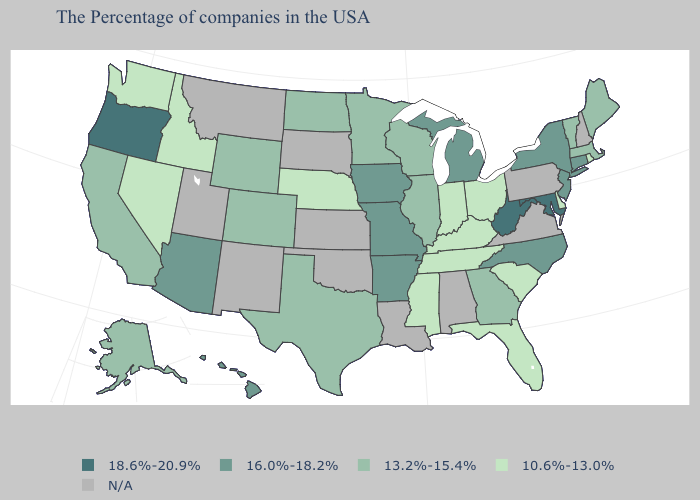Is the legend a continuous bar?
Quick response, please. No. What is the lowest value in the USA?
Give a very brief answer. 10.6%-13.0%. Which states hav the highest value in the Northeast?
Concise answer only. Connecticut, New York, New Jersey. What is the highest value in states that border Connecticut?
Be succinct. 16.0%-18.2%. How many symbols are there in the legend?
Short answer required. 5. Does the map have missing data?
Write a very short answer. Yes. Among the states that border South Dakota , which have the lowest value?
Give a very brief answer. Nebraska. What is the value of Colorado?
Concise answer only. 13.2%-15.4%. Name the states that have a value in the range N/A?
Quick response, please. New Hampshire, Pennsylvania, Virginia, Alabama, Louisiana, Kansas, Oklahoma, South Dakota, New Mexico, Utah, Montana. Does the map have missing data?
Write a very short answer. Yes. Name the states that have a value in the range 10.6%-13.0%?
Answer briefly. Rhode Island, Delaware, South Carolina, Ohio, Florida, Kentucky, Indiana, Tennessee, Mississippi, Nebraska, Idaho, Nevada, Washington. What is the value of Ohio?
Concise answer only. 10.6%-13.0%. What is the highest value in the USA?
Answer briefly. 18.6%-20.9%. Name the states that have a value in the range 18.6%-20.9%?
Write a very short answer. Maryland, West Virginia, Oregon. 